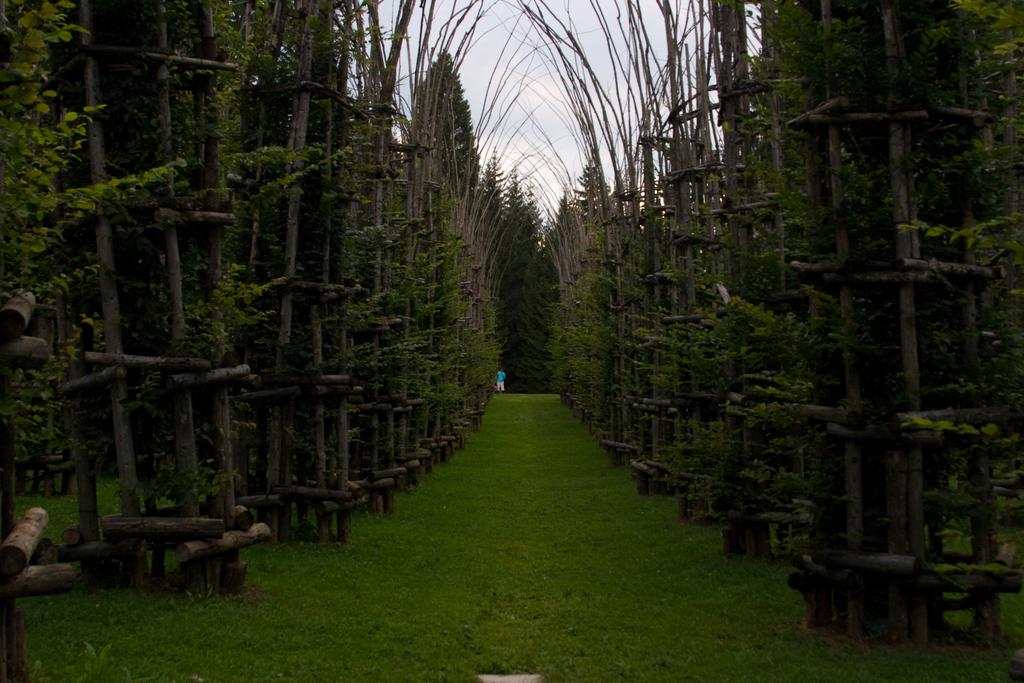What type of vegetation is present in the image? There is a group of trees in the image. What is located near the trees? The trees are beside a wooden fence. Can you describe the person in the image? There is a person standing on the grass in the image. What can be seen in the background of the image? The sky is visible in the image. How would you describe the weather based on the sky? The sky appears to be cloudy in the image. How many brothers are visible in the image? There are no brothers present in the image. What type of plate is being used by the person in the image? There is no plate visible in the image; the person is standing on the grass. 